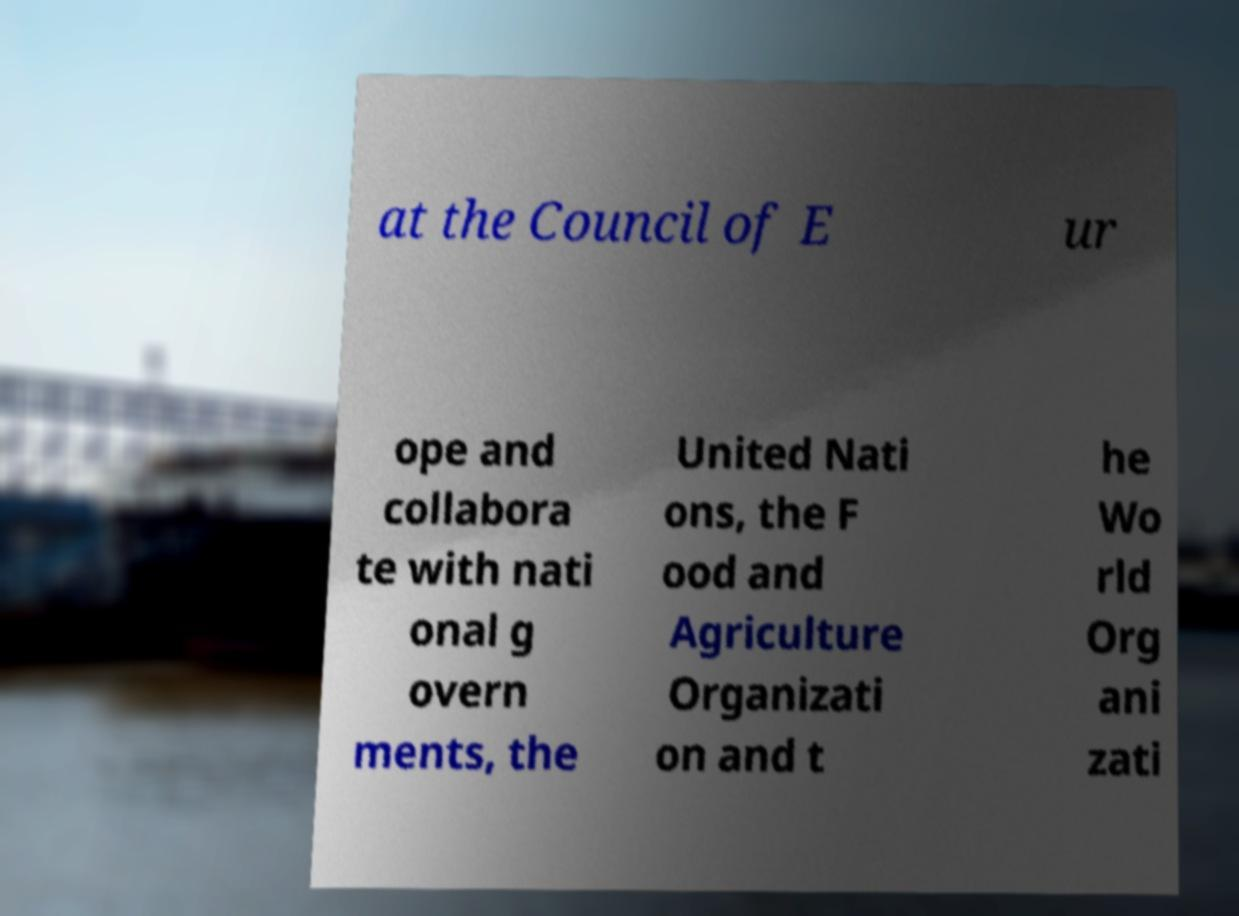Please identify and transcribe the text found in this image. at the Council of E ur ope and collabora te with nati onal g overn ments, the United Nati ons, the F ood and Agriculture Organizati on and t he Wo rld Org ani zati 